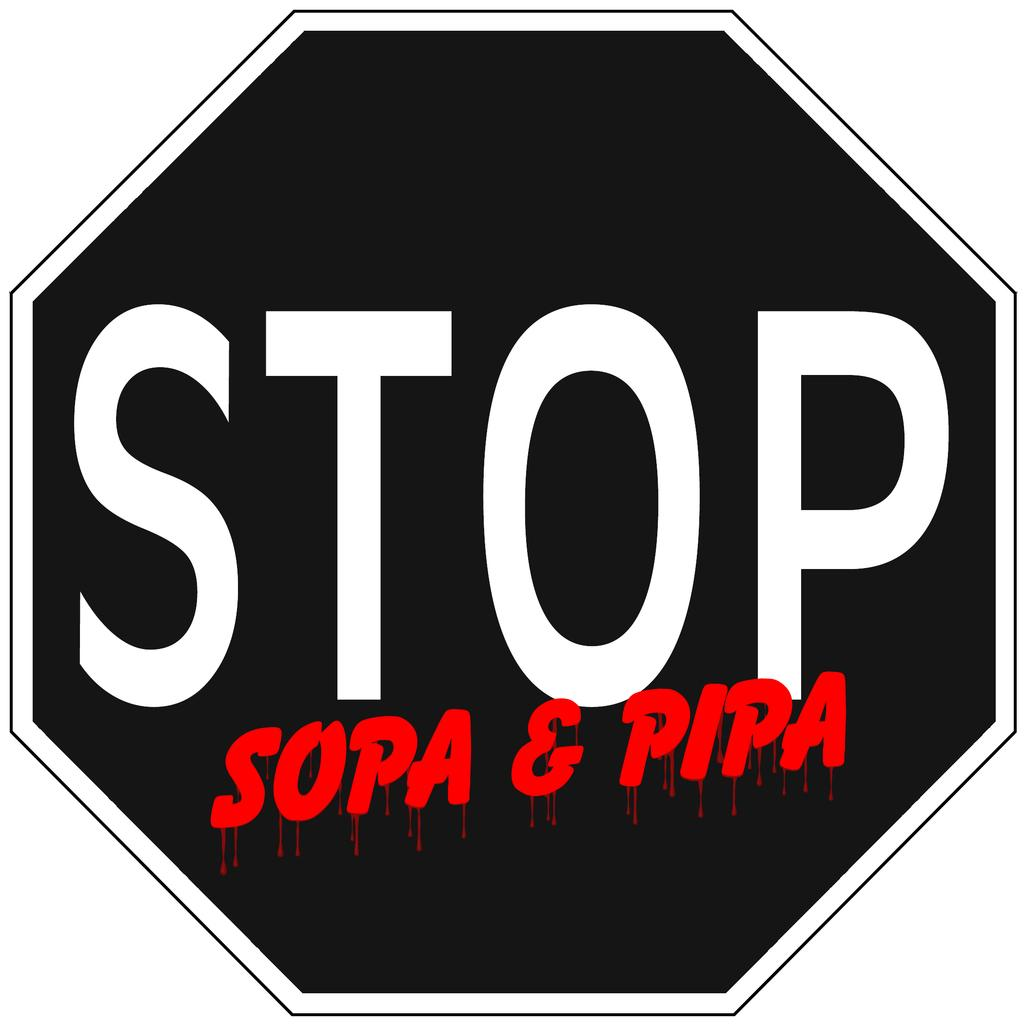<image>
Create a compact narrative representing the image presented. A black stop sign features the words Sopa & Pipa. 